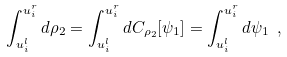<formula> <loc_0><loc_0><loc_500><loc_500>\int _ { u _ { i } ^ { l } } ^ { u _ { i } ^ { r } } d \rho _ { 2 } = \int _ { u _ { i } ^ { l } } ^ { u _ { i } ^ { r } } d C _ { \rho _ { 2 } } [ \psi _ { 1 } ] = \int _ { u _ { i } ^ { l } } ^ { u _ { i } ^ { r } } d \psi _ { 1 } \ ,</formula> 